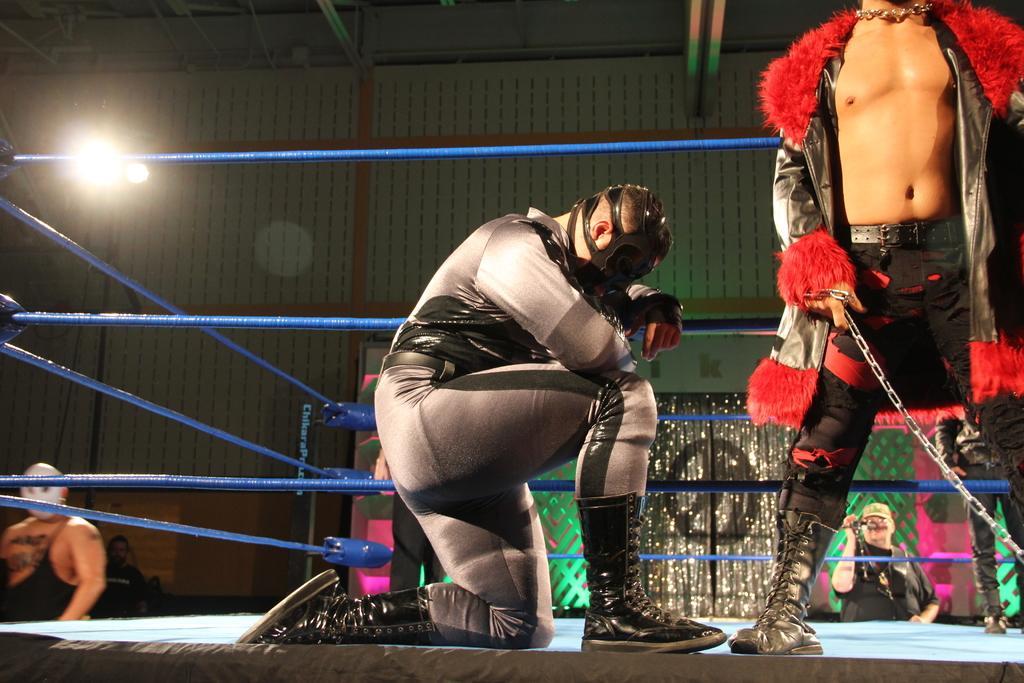Could you give a brief overview of what you see in this image? In this image I can see group of people standing. In front the person is wearing black and red color dress and holding the chain. Background I can see the person holding the camera and I can also see the light. 